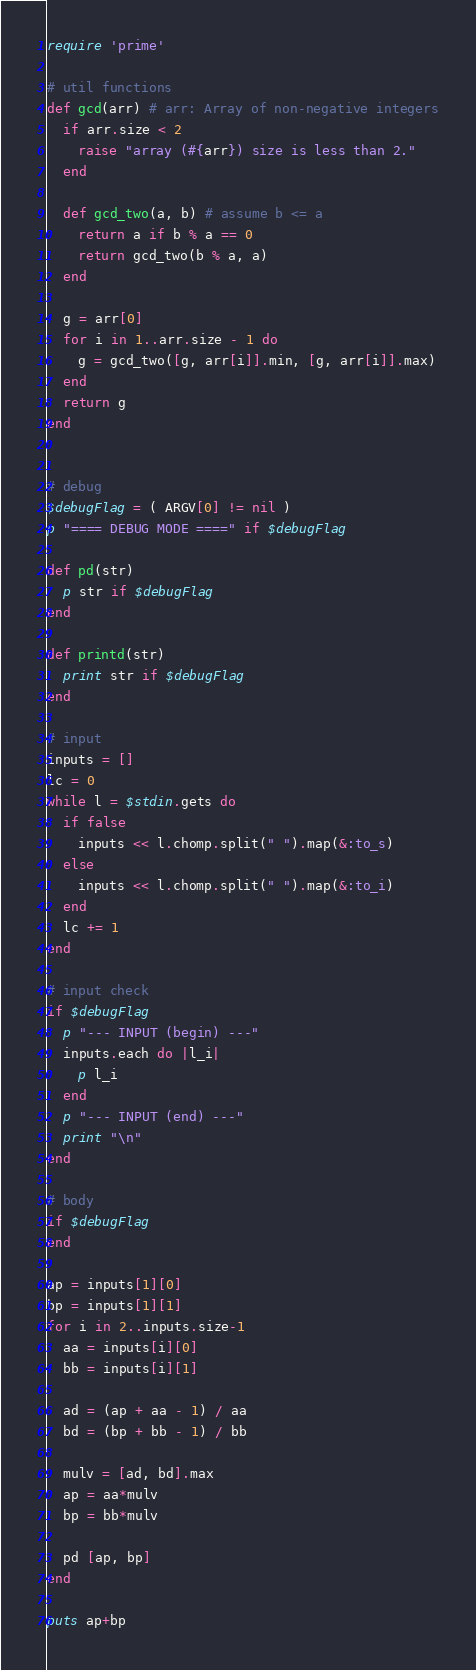Convert code to text. <code><loc_0><loc_0><loc_500><loc_500><_Ruby_>require 'prime'

# util functions
def gcd(arr) # arr: Array of non-negative integers
  if arr.size < 2
    raise "array (#{arr}) size is less than 2."
  end
  
  def gcd_two(a, b) # assume b <= a
    return a if b % a == 0
    return gcd_two(b % a, a)
  end

  g = arr[0]
  for i in 1..arr.size - 1 do
    g = gcd_two([g, arr[i]].min, [g, arr[i]].max)
  end
  return g
end


# debug
$debugFlag = ( ARGV[0] != nil )
p "==== DEBUG MODE ====" if $debugFlag

def pd(str)
  p str if $debugFlag
end

def printd(str)
  print str if $debugFlag
end

# input
inputs = []
lc = 0
while l = $stdin.gets do
  if false
    inputs << l.chomp.split(" ").map(&:to_s)
  else
    inputs << l.chomp.split(" ").map(&:to_i)
  end
  lc += 1
end

# input check
if $debugFlag
  p "--- INPUT (begin) ---"
  inputs.each do |l_i|
    p l_i
  end
  p "--- INPUT (end) ---"
  print "\n"
end

# body
if $debugFlag
end

ap = inputs[1][0]
bp = inputs[1][1]
for i in 2..inputs.size-1
  aa = inputs[i][0]
  bb = inputs[i][1]

  ad = (ap + aa - 1) / aa
  bd = (bp + bb - 1) / bb

  mulv = [ad, bd].max
  ap = aa*mulv
  bp = bb*mulv

  pd [ap, bp]
end

puts ap+bp
</code> 